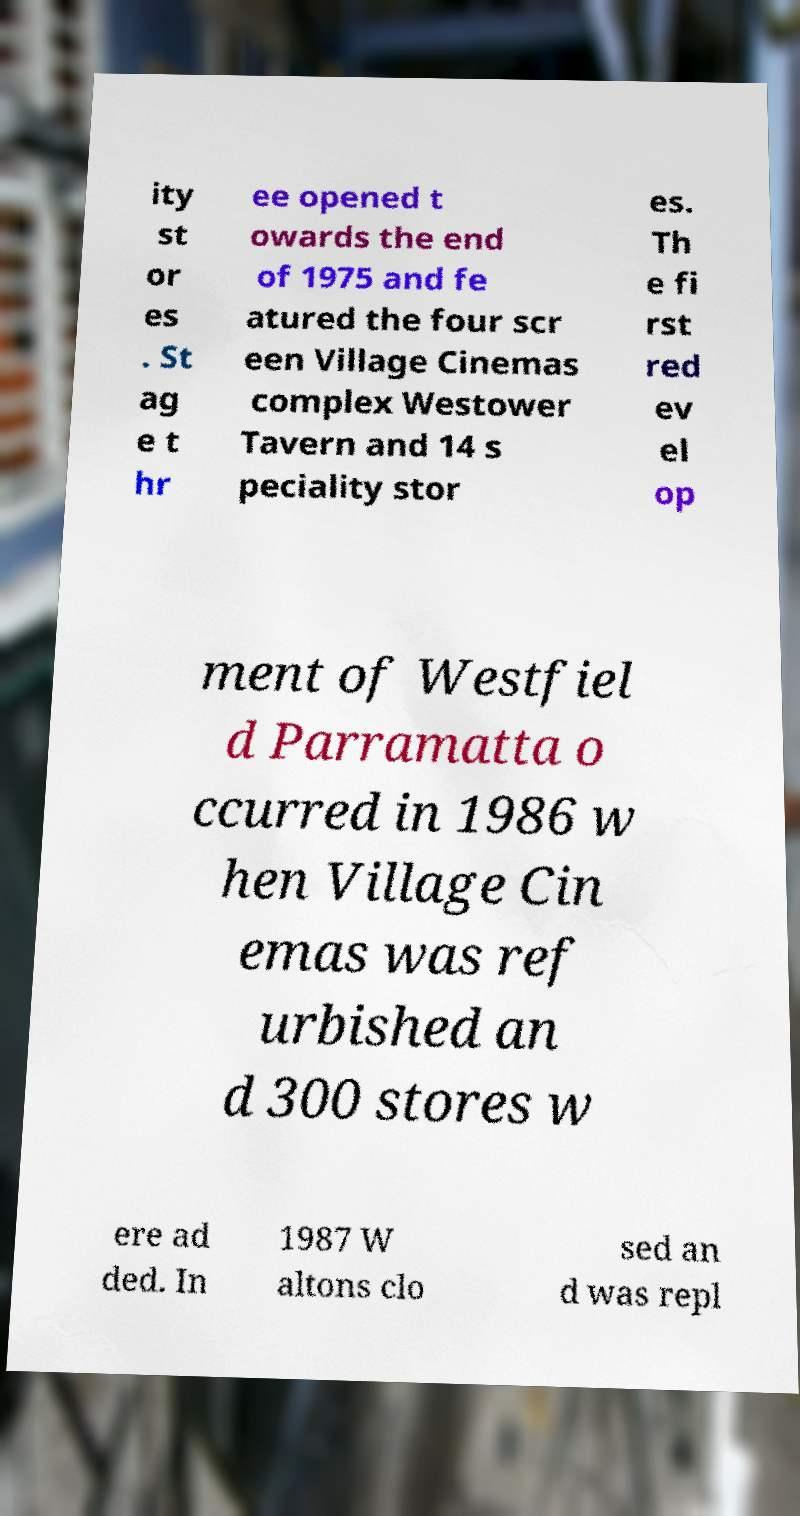I need the written content from this picture converted into text. Can you do that? ity st or es . St ag e t hr ee opened t owards the end of 1975 and fe atured the four scr een Village Cinemas complex Westower Tavern and 14 s peciality stor es. Th e fi rst red ev el op ment of Westfiel d Parramatta o ccurred in 1986 w hen Village Cin emas was ref urbished an d 300 stores w ere ad ded. In 1987 W altons clo sed an d was repl 